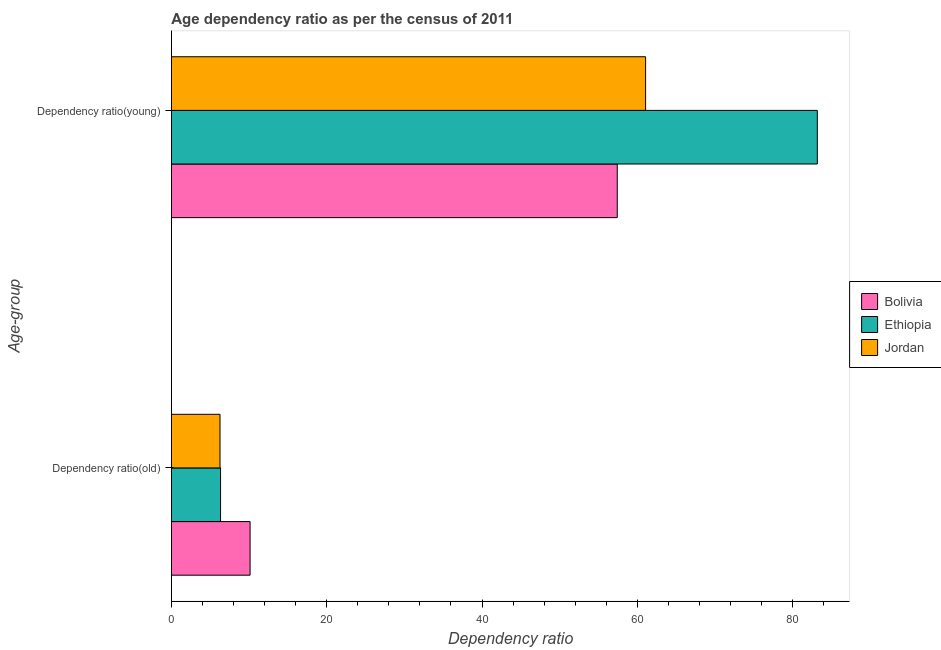How many different coloured bars are there?
Provide a succinct answer. 3. How many groups of bars are there?
Make the answer very short. 2. Are the number of bars on each tick of the Y-axis equal?
Provide a succinct answer. Yes. How many bars are there on the 1st tick from the bottom?
Your answer should be very brief. 3. What is the label of the 2nd group of bars from the top?
Keep it short and to the point. Dependency ratio(old). What is the age dependency ratio(old) in Jordan?
Provide a succinct answer. 6.26. Across all countries, what is the maximum age dependency ratio(old)?
Your response must be concise. 10.13. Across all countries, what is the minimum age dependency ratio(old)?
Your answer should be compact. 6.26. In which country was the age dependency ratio(old) minimum?
Provide a short and direct response. Jordan. What is the total age dependency ratio(young) in the graph?
Provide a succinct answer. 201.65. What is the difference between the age dependency ratio(young) in Jordan and that in Bolivia?
Offer a very short reply. 3.65. What is the difference between the age dependency ratio(old) in Ethiopia and the age dependency ratio(young) in Bolivia?
Your response must be concise. -51.08. What is the average age dependency ratio(young) per country?
Your answer should be very brief. 67.22. What is the difference between the age dependency ratio(old) and age dependency ratio(young) in Jordan?
Provide a short and direct response. -54.8. What is the ratio of the age dependency ratio(old) in Ethiopia to that in Jordan?
Provide a short and direct response. 1.01. Is the age dependency ratio(young) in Bolivia less than that in Jordan?
Give a very brief answer. Yes. What does the 2nd bar from the top in Dependency ratio(old) represents?
Your answer should be very brief. Ethiopia. What does the 2nd bar from the bottom in Dependency ratio(old) represents?
Make the answer very short. Ethiopia. How many bars are there?
Offer a terse response. 6. Are all the bars in the graph horizontal?
Offer a terse response. Yes. How many countries are there in the graph?
Make the answer very short. 3. What is the difference between two consecutive major ticks on the X-axis?
Provide a short and direct response. 20. Are the values on the major ticks of X-axis written in scientific E-notation?
Ensure brevity in your answer.  No. Where does the legend appear in the graph?
Ensure brevity in your answer.  Center right. What is the title of the graph?
Your answer should be compact. Age dependency ratio as per the census of 2011. What is the label or title of the X-axis?
Your answer should be very brief. Dependency ratio. What is the label or title of the Y-axis?
Your answer should be compact. Age-group. What is the Dependency ratio of Bolivia in Dependency ratio(old)?
Your answer should be compact. 10.13. What is the Dependency ratio of Ethiopia in Dependency ratio(old)?
Offer a terse response. 6.33. What is the Dependency ratio in Jordan in Dependency ratio(old)?
Your response must be concise. 6.26. What is the Dependency ratio in Bolivia in Dependency ratio(young)?
Keep it short and to the point. 57.41. What is the Dependency ratio of Ethiopia in Dependency ratio(young)?
Ensure brevity in your answer.  83.17. What is the Dependency ratio of Jordan in Dependency ratio(young)?
Ensure brevity in your answer.  61.06. Across all Age-group, what is the maximum Dependency ratio in Bolivia?
Ensure brevity in your answer.  57.41. Across all Age-group, what is the maximum Dependency ratio in Ethiopia?
Offer a terse response. 83.17. Across all Age-group, what is the maximum Dependency ratio of Jordan?
Your response must be concise. 61.06. Across all Age-group, what is the minimum Dependency ratio of Bolivia?
Your answer should be very brief. 10.13. Across all Age-group, what is the minimum Dependency ratio in Ethiopia?
Provide a succinct answer. 6.33. Across all Age-group, what is the minimum Dependency ratio of Jordan?
Your response must be concise. 6.26. What is the total Dependency ratio in Bolivia in the graph?
Provide a succinct answer. 67.55. What is the total Dependency ratio of Ethiopia in the graph?
Keep it short and to the point. 89.5. What is the total Dependency ratio of Jordan in the graph?
Provide a succinct answer. 67.33. What is the difference between the Dependency ratio in Bolivia in Dependency ratio(old) and that in Dependency ratio(young)?
Make the answer very short. -47.28. What is the difference between the Dependency ratio in Ethiopia in Dependency ratio(old) and that in Dependency ratio(young)?
Make the answer very short. -76.84. What is the difference between the Dependency ratio in Jordan in Dependency ratio(old) and that in Dependency ratio(young)?
Ensure brevity in your answer.  -54.8. What is the difference between the Dependency ratio in Bolivia in Dependency ratio(old) and the Dependency ratio in Ethiopia in Dependency ratio(young)?
Offer a very short reply. -73.04. What is the difference between the Dependency ratio in Bolivia in Dependency ratio(old) and the Dependency ratio in Jordan in Dependency ratio(young)?
Provide a succinct answer. -50.93. What is the difference between the Dependency ratio in Ethiopia in Dependency ratio(old) and the Dependency ratio in Jordan in Dependency ratio(young)?
Provide a short and direct response. -54.73. What is the average Dependency ratio of Bolivia per Age-group?
Keep it short and to the point. 33.77. What is the average Dependency ratio of Ethiopia per Age-group?
Keep it short and to the point. 44.75. What is the average Dependency ratio of Jordan per Age-group?
Give a very brief answer. 33.66. What is the difference between the Dependency ratio in Bolivia and Dependency ratio in Ethiopia in Dependency ratio(old)?
Offer a terse response. 3.8. What is the difference between the Dependency ratio in Bolivia and Dependency ratio in Jordan in Dependency ratio(old)?
Make the answer very short. 3.87. What is the difference between the Dependency ratio of Ethiopia and Dependency ratio of Jordan in Dependency ratio(old)?
Make the answer very short. 0.07. What is the difference between the Dependency ratio of Bolivia and Dependency ratio of Ethiopia in Dependency ratio(young)?
Ensure brevity in your answer.  -25.76. What is the difference between the Dependency ratio of Bolivia and Dependency ratio of Jordan in Dependency ratio(young)?
Make the answer very short. -3.65. What is the difference between the Dependency ratio of Ethiopia and Dependency ratio of Jordan in Dependency ratio(young)?
Your answer should be compact. 22.11. What is the ratio of the Dependency ratio in Bolivia in Dependency ratio(old) to that in Dependency ratio(young)?
Make the answer very short. 0.18. What is the ratio of the Dependency ratio in Ethiopia in Dependency ratio(old) to that in Dependency ratio(young)?
Ensure brevity in your answer.  0.08. What is the ratio of the Dependency ratio of Jordan in Dependency ratio(old) to that in Dependency ratio(young)?
Ensure brevity in your answer.  0.1. What is the difference between the highest and the second highest Dependency ratio of Bolivia?
Your answer should be compact. 47.28. What is the difference between the highest and the second highest Dependency ratio in Ethiopia?
Keep it short and to the point. 76.84. What is the difference between the highest and the second highest Dependency ratio of Jordan?
Offer a terse response. 54.8. What is the difference between the highest and the lowest Dependency ratio in Bolivia?
Ensure brevity in your answer.  47.28. What is the difference between the highest and the lowest Dependency ratio of Ethiopia?
Give a very brief answer. 76.84. What is the difference between the highest and the lowest Dependency ratio of Jordan?
Offer a terse response. 54.8. 